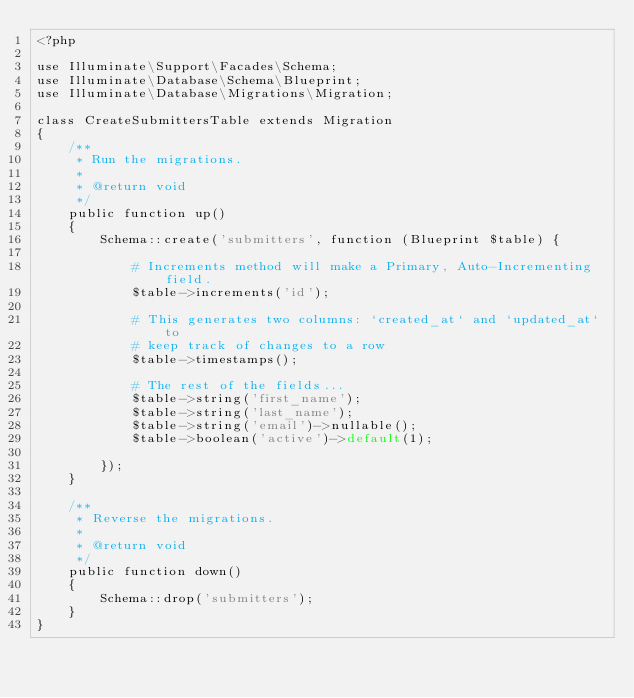<code> <loc_0><loc_0><loc_500><loc_500><_PHP_><?php

use Illuminate\Support\Facades\Schema;
use Illuminate\Database\Schema\Blueprint;
use Illuminate\Database\Migrations\Migration;

class CreateSubmittersTable extends Migration
{
    /**
     * Run the migrations.
     *
     * @return void
     */
    public function up()
    {
        Schema::create('submitters', function (Blueprint $table) {

            # Increments method will make a Primary, Auto-Incrementing field.
            $table->increments('id');

            # This generates two columns: `created_at` and `updated_at` to
            # keep track of changes to a row
            $table->timestamps();

            # The rest of the fields...
            $table->string('first_name');
            $table->string('last_name');
            $table->string('email')->nullable();
            $table->boolean('active')->default(1);            

        });
    }

    /**
     * Reverse the migrations.
     *
     * @return void
     */
    public function down()
    {
        Schema::drop('submitters');
    }
}
</code> 